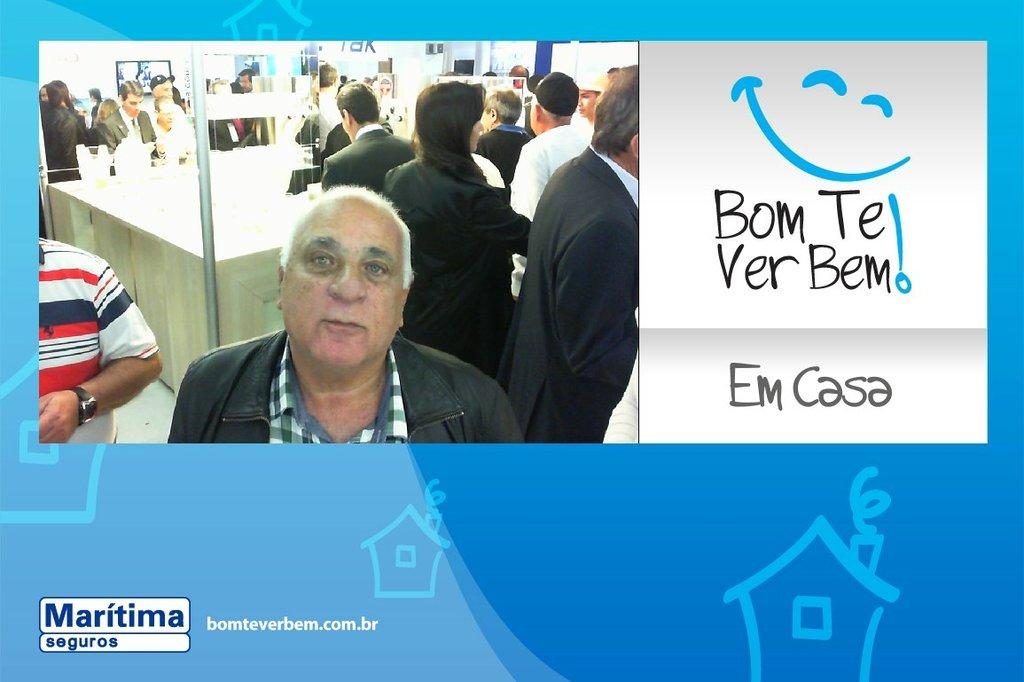<image>
Render a clear and concise summary of the photo. A group of people are looking at a display for Maritima seguros. 